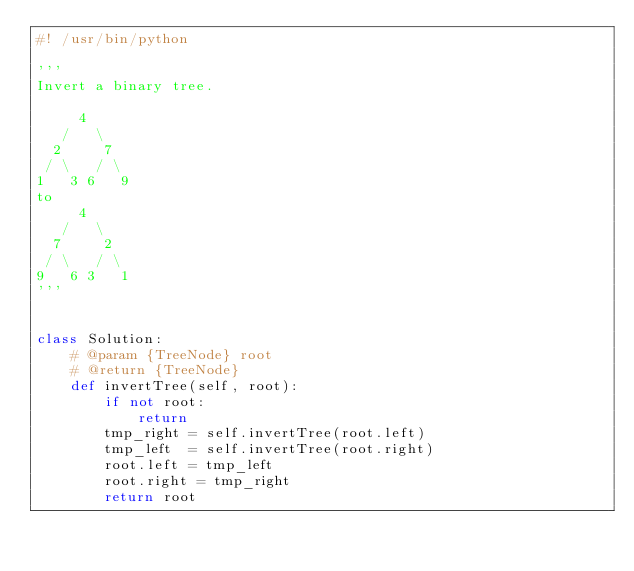Convert code to text. <code><loc_0><loc_0><loc_500><loc_500><_Python_>#! /usr/bin/python

'''
Invert a binary tree.

     4
   /   \
  2     7
 / \   / \
1   3 6   9
to
     4
   /   \
  7     2
 / \   / \
9   6 3   1
'''


class Solution:
    # @param {TreeNode} root
    # @return {TreeNode}
    def invertTree(self, root):
        if not root:
            return
        tmp_right = self.invertTree(root.left)
        tmp_left  = self.invertTree(root.right)
        root.left = tmp_left
        root.right = tmp_right
        return root
</code> 